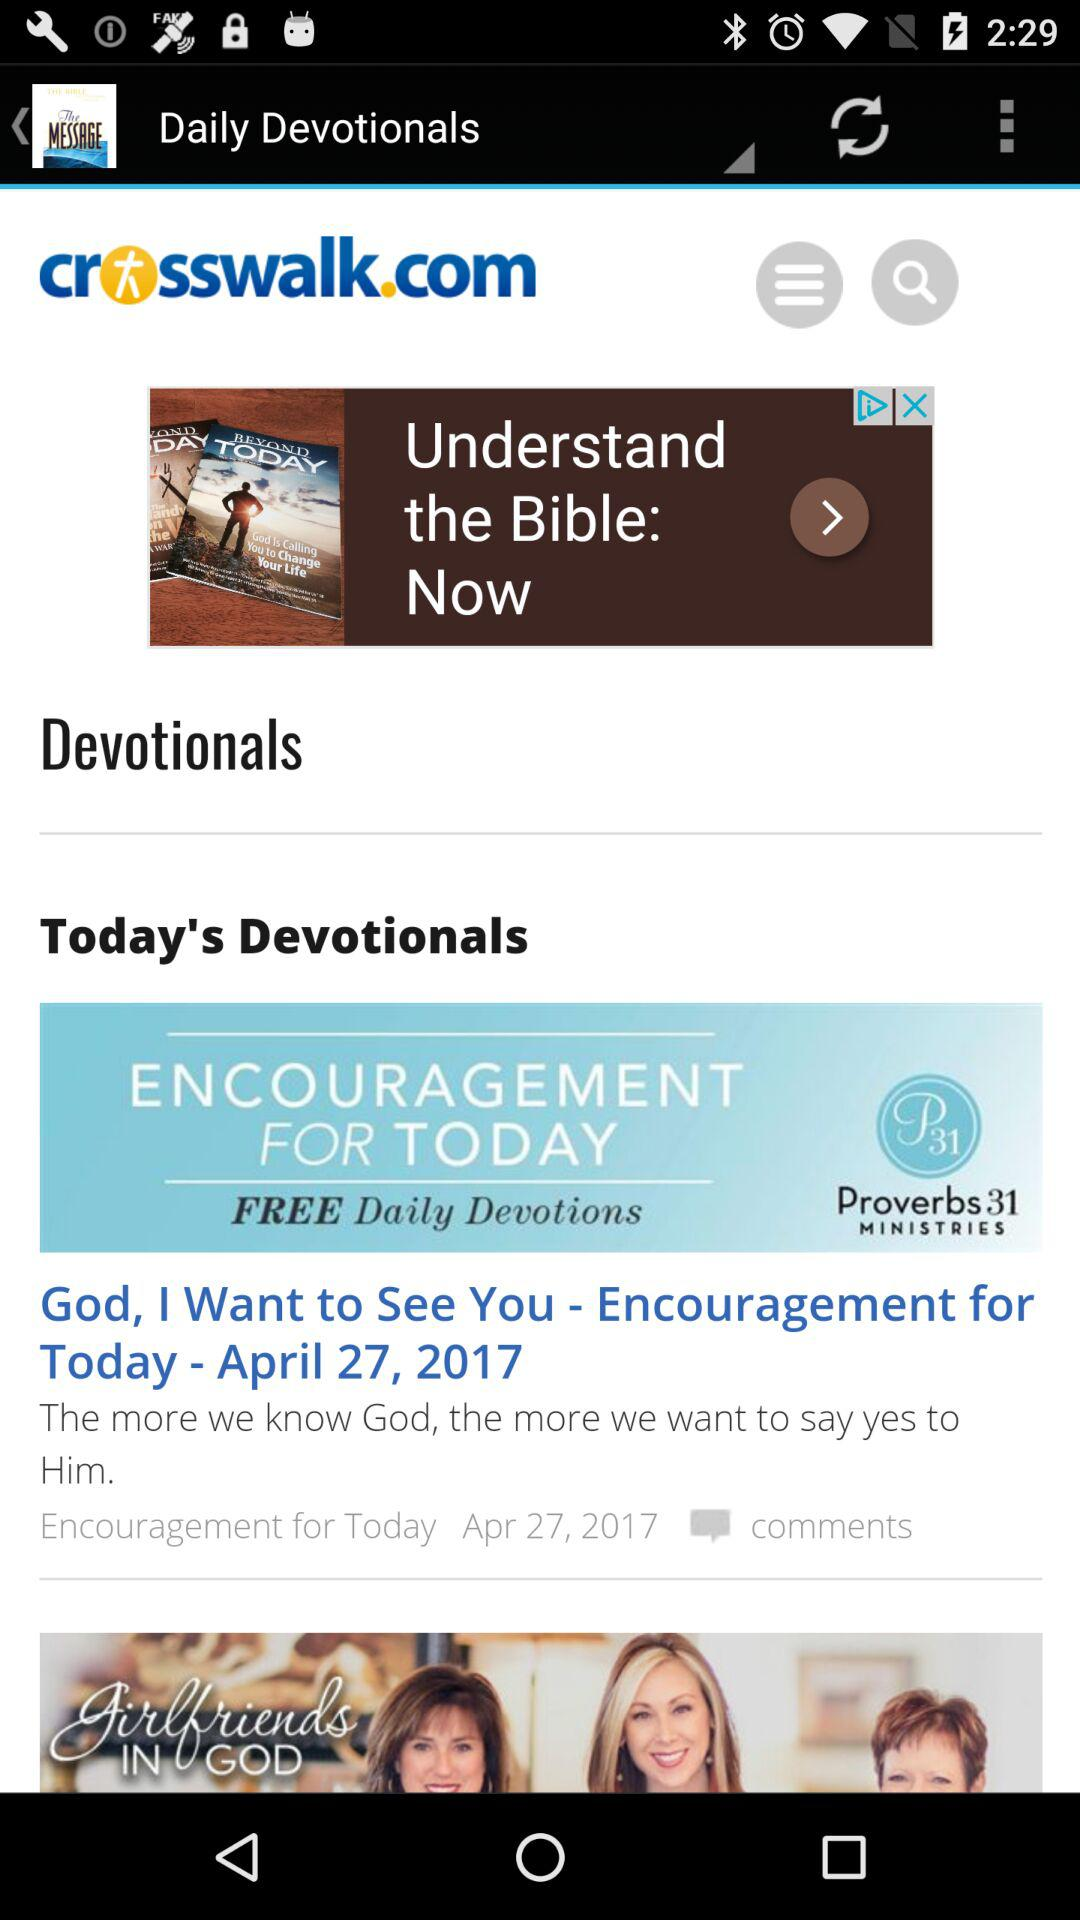What was the devotional for April 26, 2017?
When the provided information is insufficient, respond with <no answer>. <no answer> 